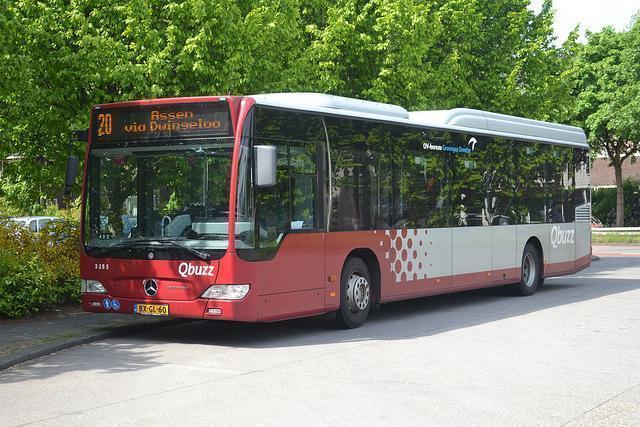What group of people are accommodated in this bus?
From the following four choices, select the correct answer to address the question.
Options: Handicapped, elderly, blind, pregnant women. Handicapped. 